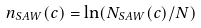<formula> <loc_0><loc_0><loc_500><loc_500>n _ { S A W } ( c ) = \ln ( N _ { S A W } ( c ) / N )</formula> 